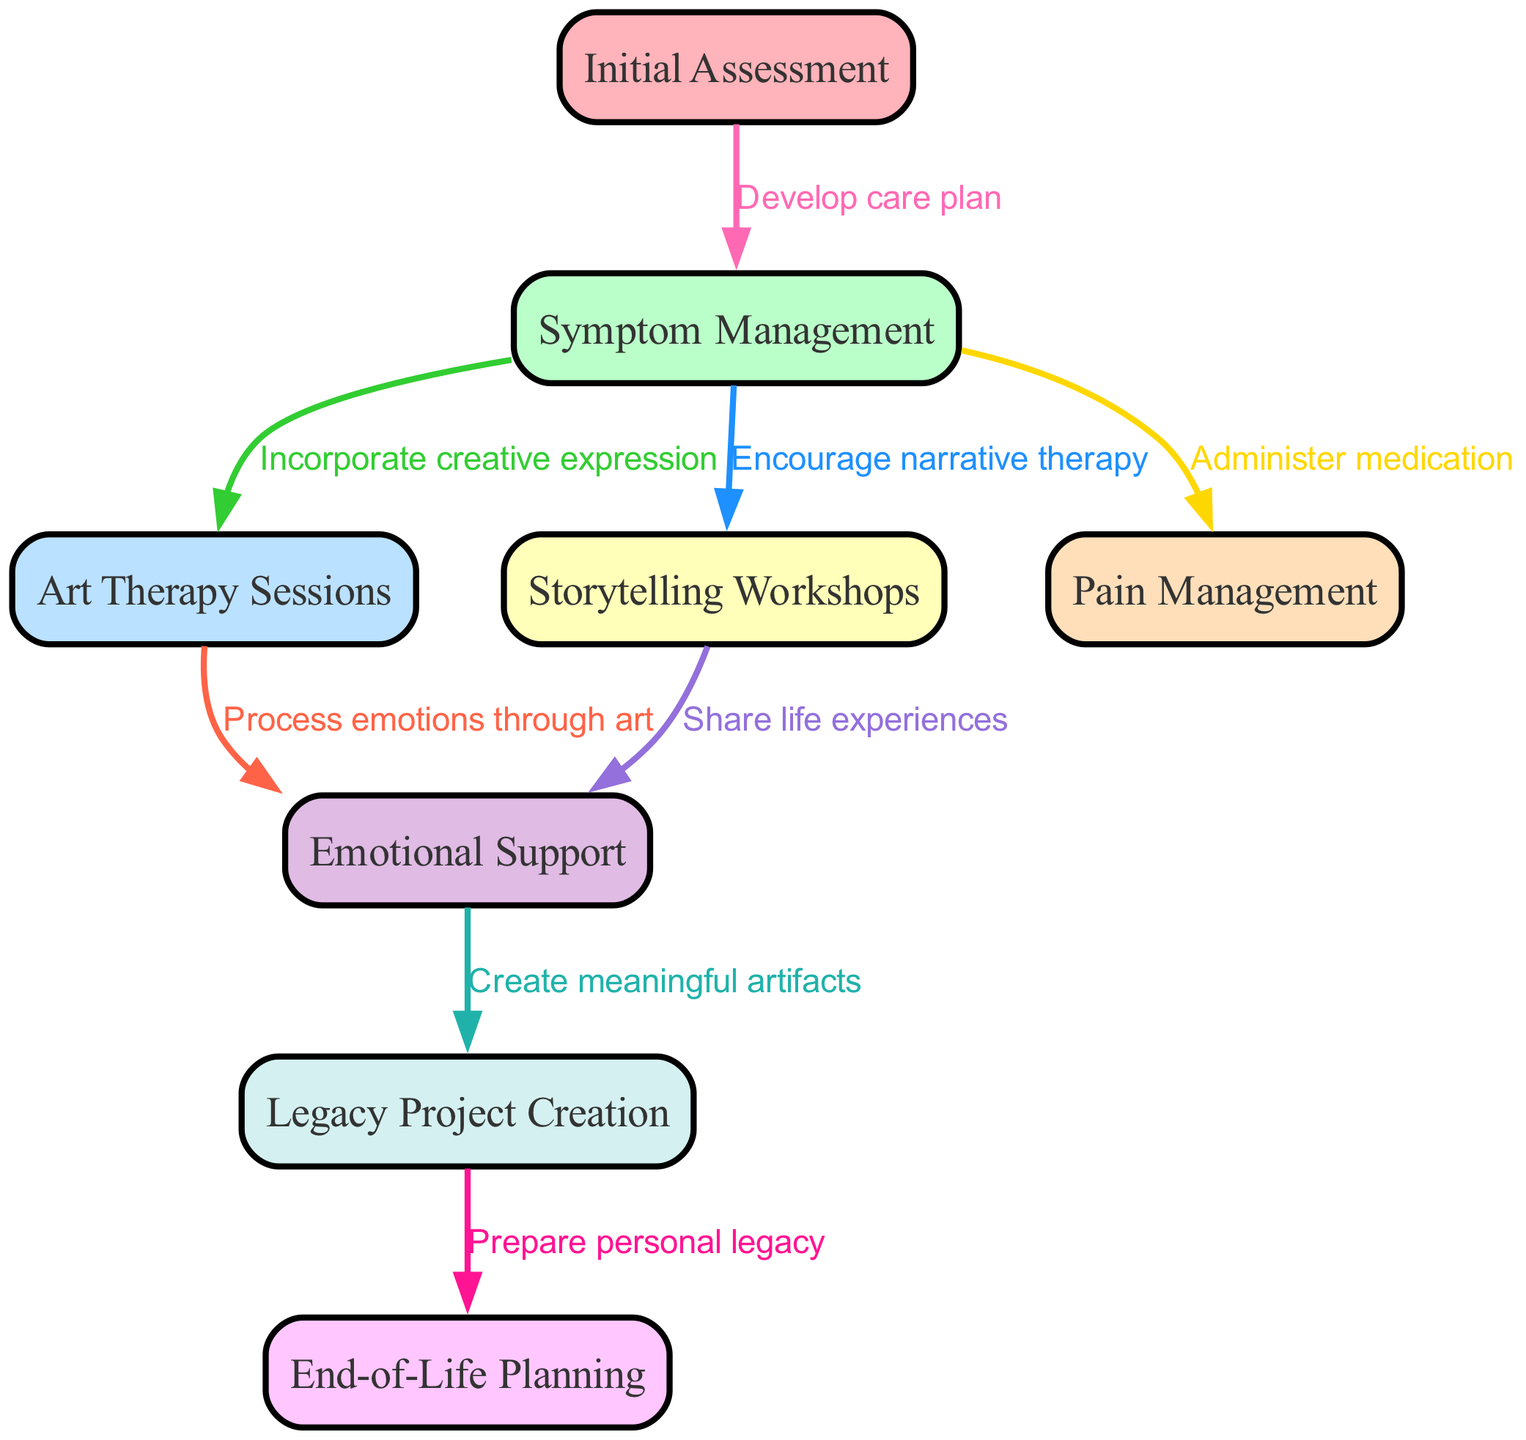What is the first step in the palliative care pathway? The first step is represented by the node labeled "Initial Assessment," which highlights the initial stage of the care process.
Answer: Initial Assessment How many nodes are present in the diagram? The diagram includes eight distinct nodes that represent different stages of the palliative care pathway.
Answer: 8 What relationship exists between "Symptom Management" and "Art Therapy Sessions"? The edge from "Symptom Management" to "Art Therapy Sessions" is labeled "Incorporate creative expression," indicating that art therapy is incorporated during symptom management.
Answer: Incorporate creative expression Which node provides emotional support in the pathway? The node labeled "Emotional Support" directly addresses the emotional aspect, serving as a crucial element within the care pathway.
Answer: Emotional Support What is created as a result of processing emotions through art? The relationship from "Art Therapy Sessions" to "Emotional Support" emphasizes that processing emotions through art contributes to emotional support for the patient.
Answer: Emotional Support What is the final outcome of the Legacy Project Creation node? The arrow leading from "Legacy Project Creation" flows to "End-of-Life Planning," indicating that the completion of legacy projects aids in the planning process for end-of-life considerations.
Answer: End-of-Life Planning What type of therapy is associated with the "Storytelling Workshops" node? The edge from "Symptom Management" to "Storytelling Workshops" indicates that narrative therapy is encouraged as part of the care approach, highlighting the therapeutic use of storytelling.
Answer: Narrative therapy How does the diagram indicate pain is managed? The node labeled "Pain Management" is connected to "Symptom Management," showing that it is a key part of managing symptoms within the care pathway.
Answer: Administer medication What is the purpose of the Legacy Project Creation in this pathway? The node "Legacy Project Creation" leads to "Prepare personal legacy," suggesting that creating legacy projects serves the purpose of helping individuals prepare meaningful reflections of their lives.
Answer: Prepare personal legacy 